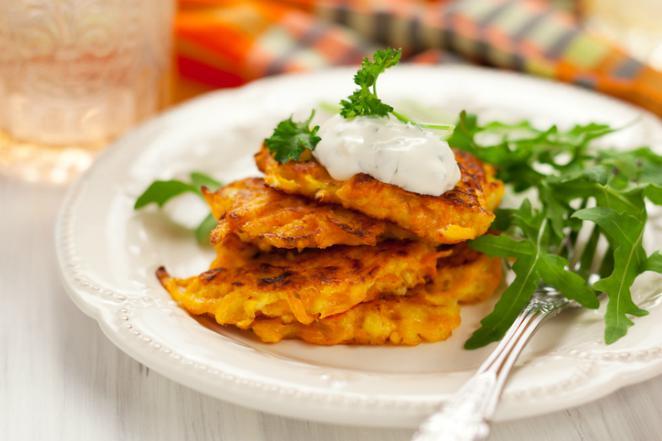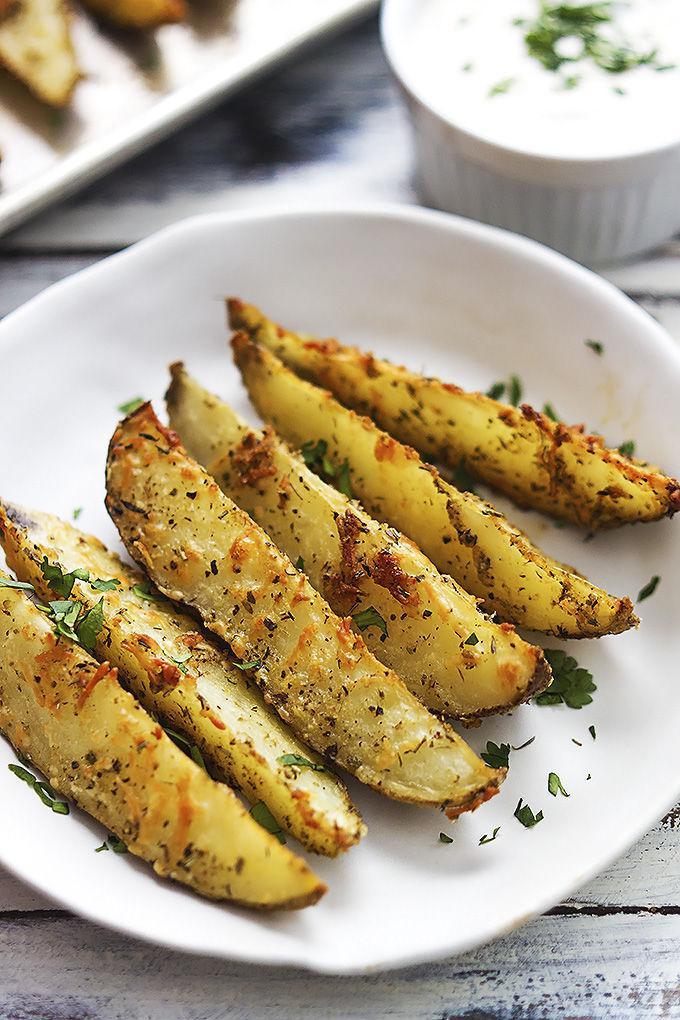The first image is the image on the left, the second image is the image on the right. Assess this claim about the two images: "One image shows stacked disk shapes garnished with green sprigs, and the other image features something creamy with broccoli florets in it.". Correct or not? Answer yes or no. No. The first image is the image on the left, the second image is the image on the right. Analyze the images presented: Is the assertion "At least one of the items is topped with a white sauce." valid? Answer yes or no. Yes. 